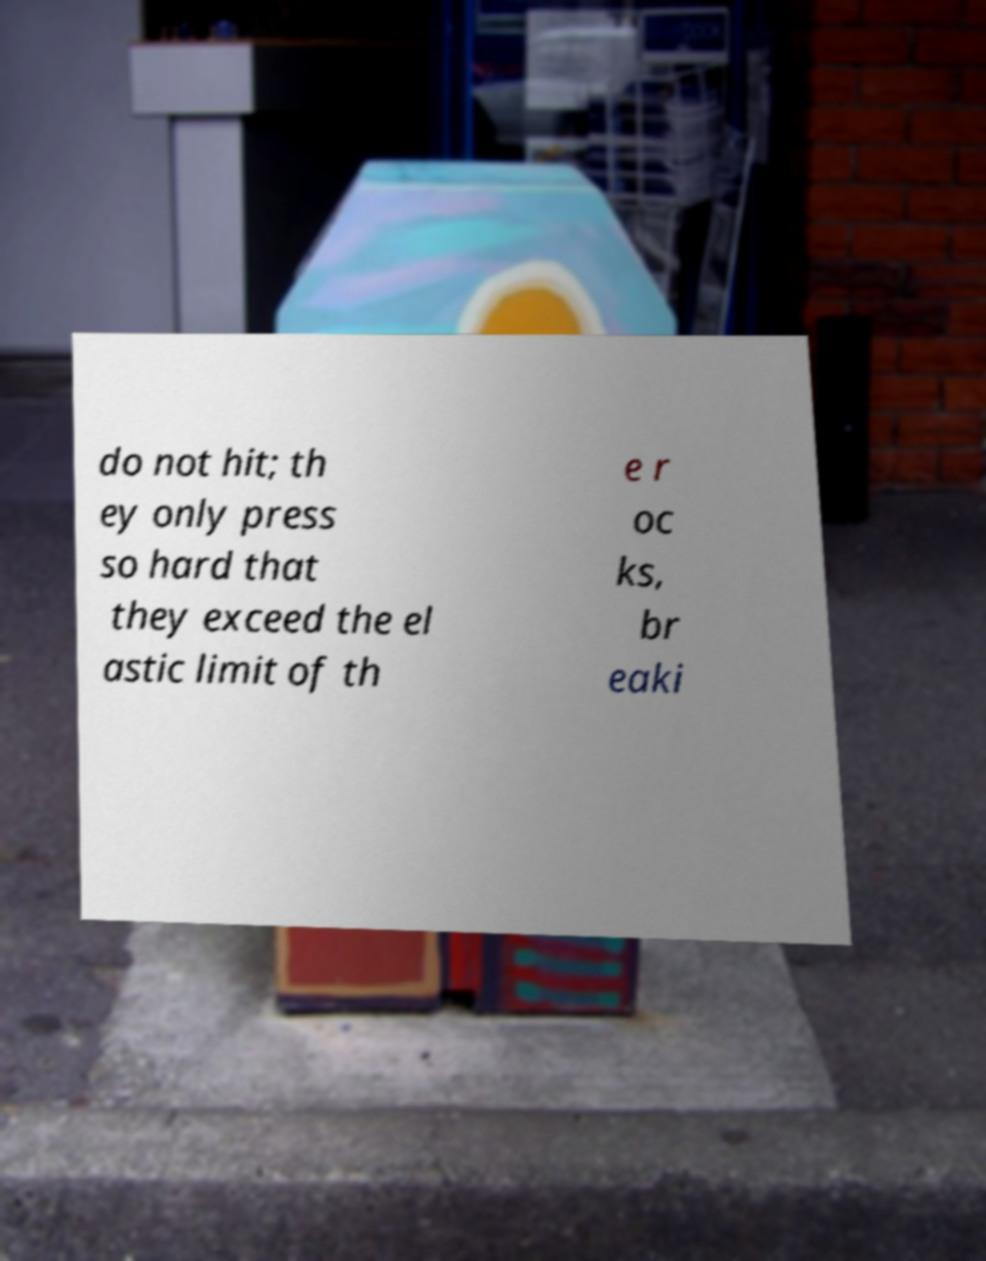There's text embedded in this image that I need extracted. Can you transcribe it verbatim? do not hit; th ey only press so hard that they exceed the el astic limit of th e r oc ks, br eaki 